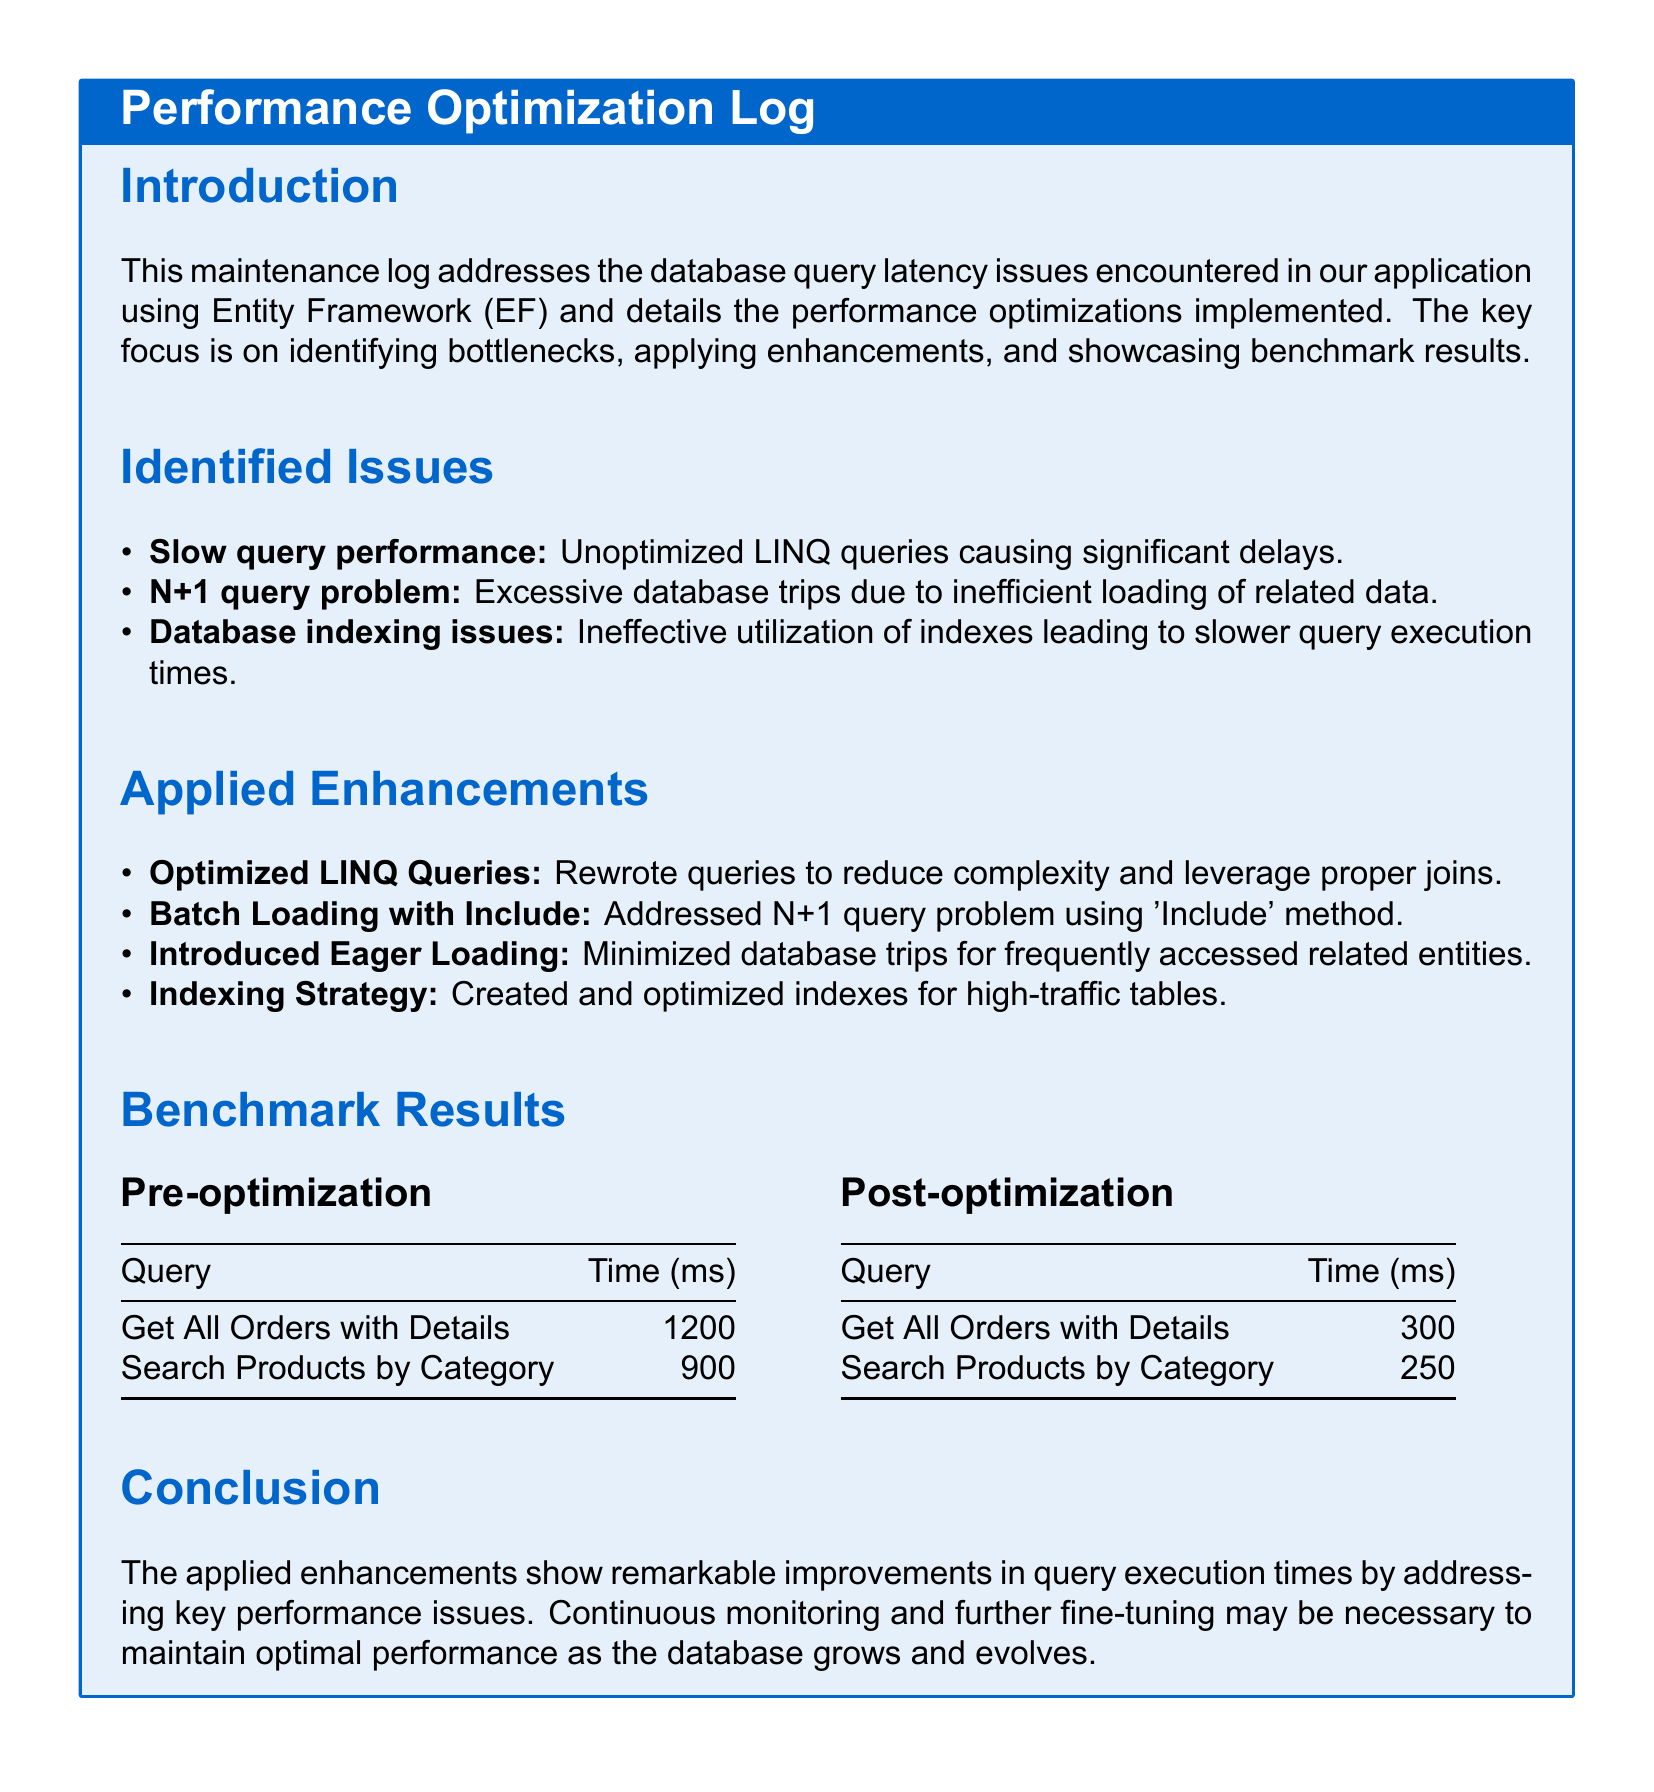What were the identified issues regarding query performance? The identified issues include slow query performance, N+1 query problem, and database indexing issues.
Answer: Slow query performance, N+1 query problem, database indexing issues What was the time (in ms) for "Get All Orders with Details" before optimization? The pre-optimization time for the query "Get All Orders with Details" is listed in the benchmark results section.
Answer: 1200 Which enhancement was applied to address the N+1 query problem? The applied enhancements include specific strategies mentioned in the document related to the N+1 query problem.
Answer: Batch Loading with Include What was the post-optimization time (in ms) for "Search Products by Category"? The post-optimization time for the query is provided in the benchmark results section of the document.
Answer: 250 What was the improvement in time (in ms) for "Get All Orders with Details" after the optimizations? The improvement can be calculated by comparing the pre-optimization and post-optimization times for the query.
Answer: 900 What strategy was introduced to minimize database trips? The document specifies a particular strategy that was used to reduce database trips for related entities.
Answer: Introduced Eager Loading How many enhancements were applied in total? The applied enhancements can be counted from the list provided in the document.
Answer: Four What is the main focus of the Maintenance log? The title and introduction sections of the document clarify the primary objective of the log.
Answer: Addressing database query latency issues What database tool is mentioned in this log? The document specifically mentions a particular database framework utilized in the application.
Answer: Entity Framework 